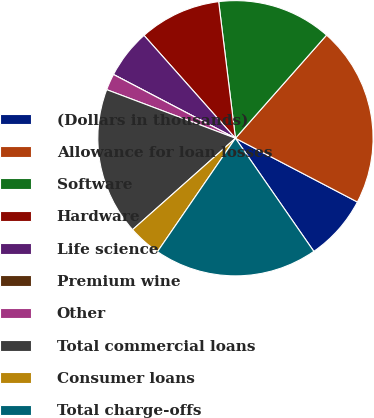<chart> <loc_0><loc_0><loc_500><loc_500><pie_chart><fcel>(Dollars in thousands)<fcel>Allowance for loan losses<fcel>Software<fcel>Hardware<fcel>Life science<fcel>Premium wine<fcel>Other<fcel>Total commercial loans<fcel>Consumer loans<fcel>Total charge-offs<nl><fcel>7.69%<fcel>21.15%<fcel>13.46%<fcel>9.62%<fcel>5.77%<fcel>0.0%<fcel>1.92%<fcel>17.31%<fcel>3.85%<fcel>19.23%<nl></chart> 